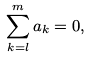Convert formula to latex. <formula><loc_0><loc_0><loc_500><loc_500>\sum _ { k = l } ^ { m } a _ { k } = 0 ,</formula> 